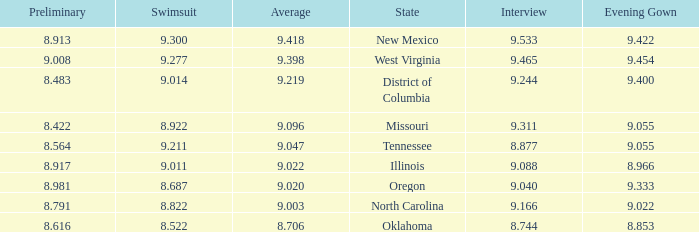Name the swuinsuit for oregon 8.687. 